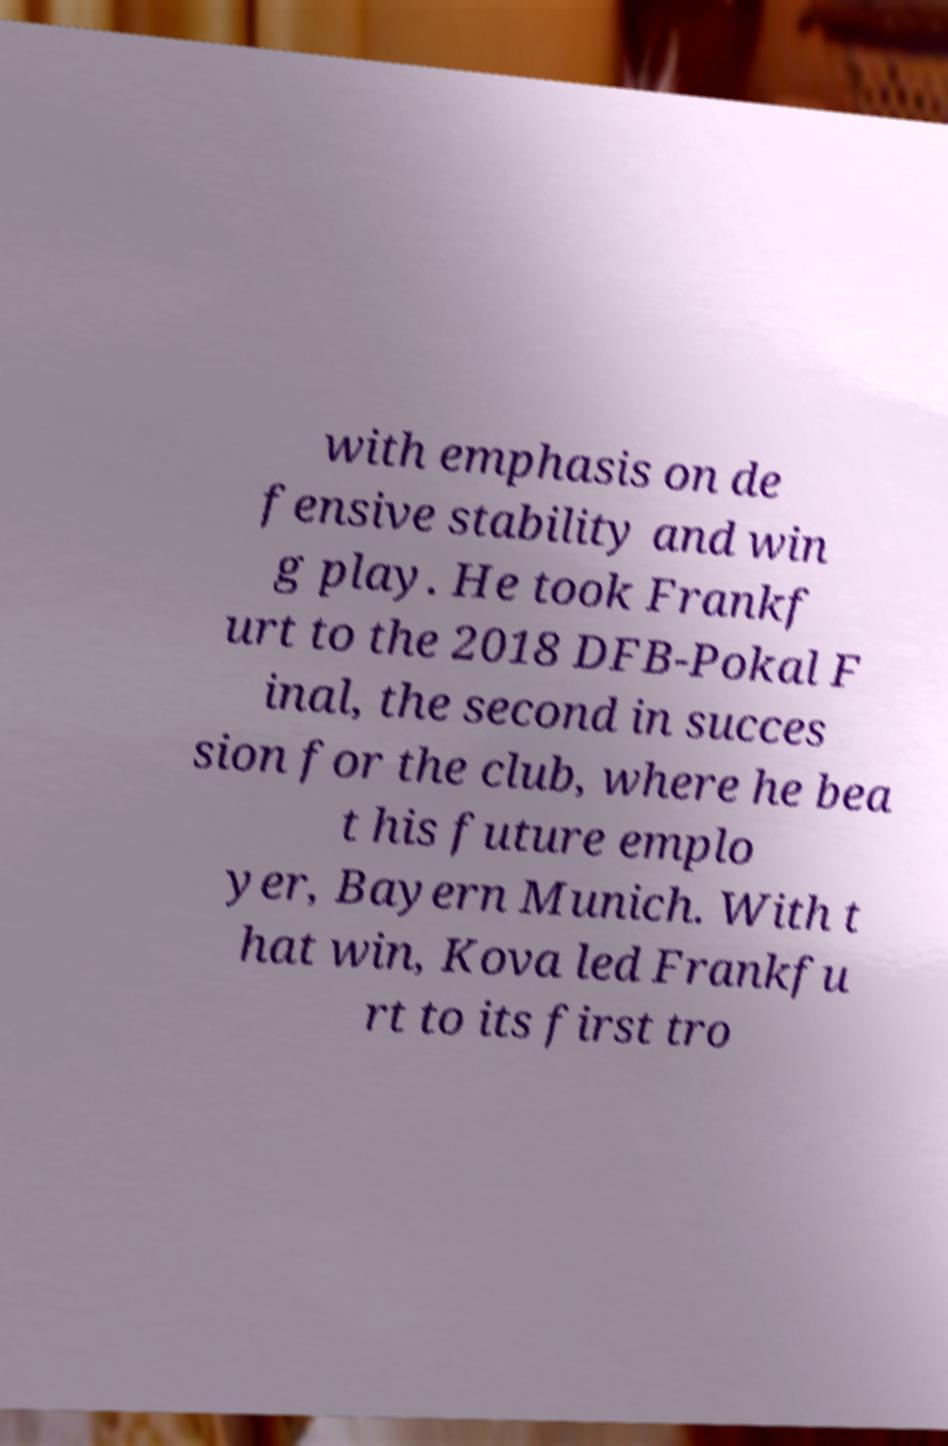What messages or text are displayed in this image? I need them in a readable, typed format. with emphasis on de fensive stability and win g play. He took Frankf urt to the 2018 DFB-Pokal F inal, the second in succes sion for the club, where he bea t his future emplo yer, Bayern Munich. With t hat win, Kova led Frankfu rt to its first tro 